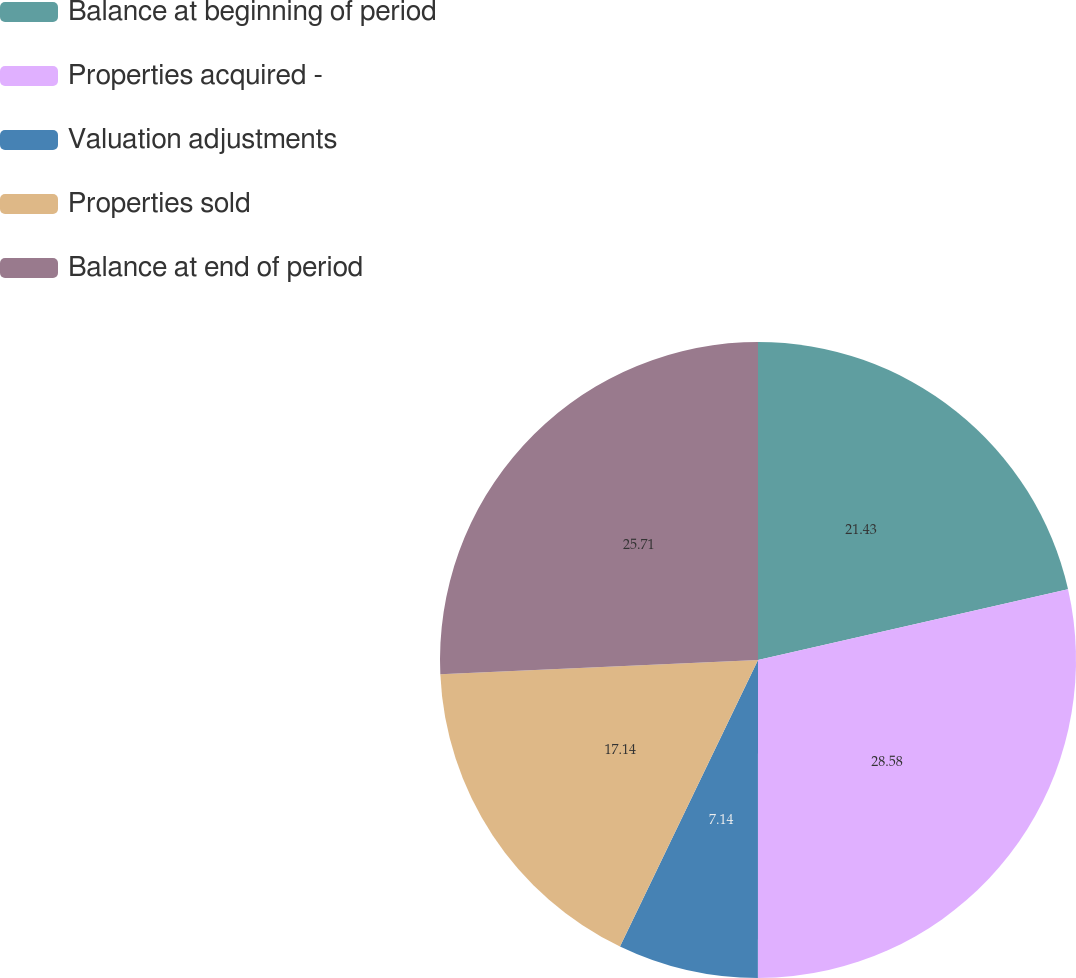Convert chart to OTSL. <chart><loc_0><loc_0><loc_500><loc_500><pie_chart><fcel>Balance at beginning of period<fcel>Properties acquired -<fcel>Valuation adjustments<fcel>Properties sold<fcel>Balance at end of period<nl><fcel>21.43%<fcel>28.57%<fcel>7.14%<fcel>17.14%<fcel>25.71%<nl></chart> 